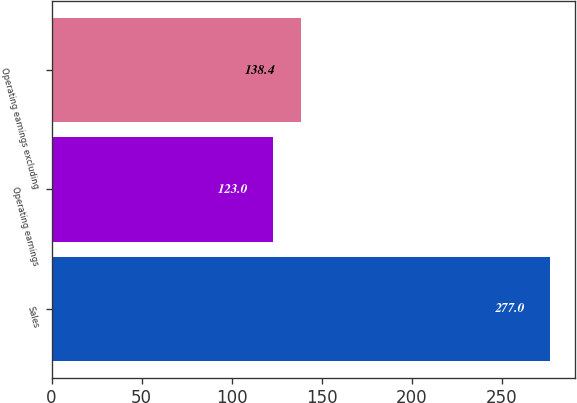Convert chart to OTSL. <chart><loc_0><loc_0><loc_500><loc_500><bar_chart><fcel>Sales<fcel>Operating earnings<fcel>Operating earnings excluding<nl><fcel>277<fcel>123<fcel>138.4<nl></chart> 